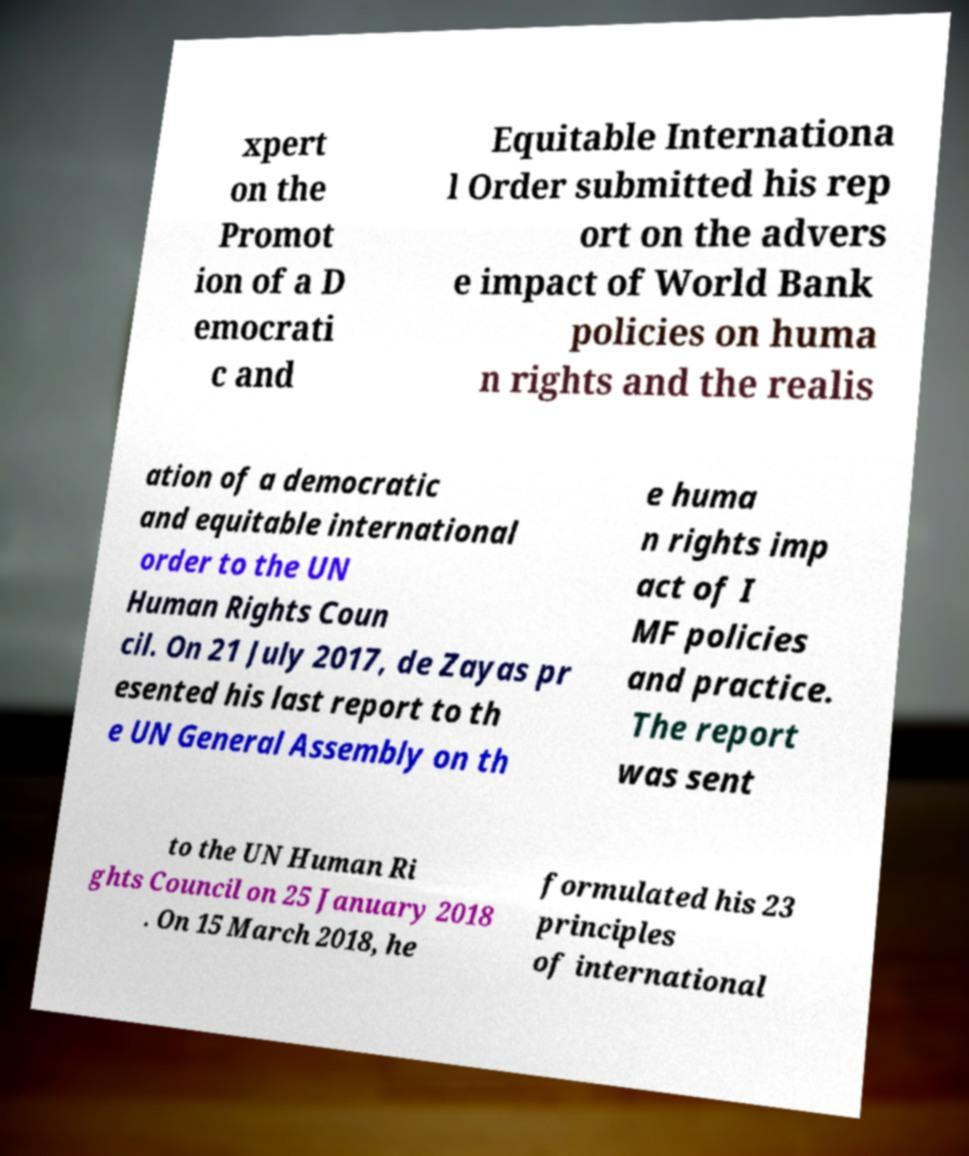There's text embedded in this image that I need extracted. Can you transcribe it verbatim? xpert on the Promot ion of a D emocrati c and Equitable Internationa l Order submitted his rep ort on the advers e impact of World Bank policies on huma n rights and the realis ation of a democratic and equitable international order to the UN Human Rights Coun cil. On 21 July 2017, de Zayas pr esented his last report to th e UN General Assembly on th e huma n rights imp act of I MF policies and practice. The report was sent to the UN Human Ri ghts Council on 25 January 2018 . On 15 March 2018, he formulated his 23 principles of international 